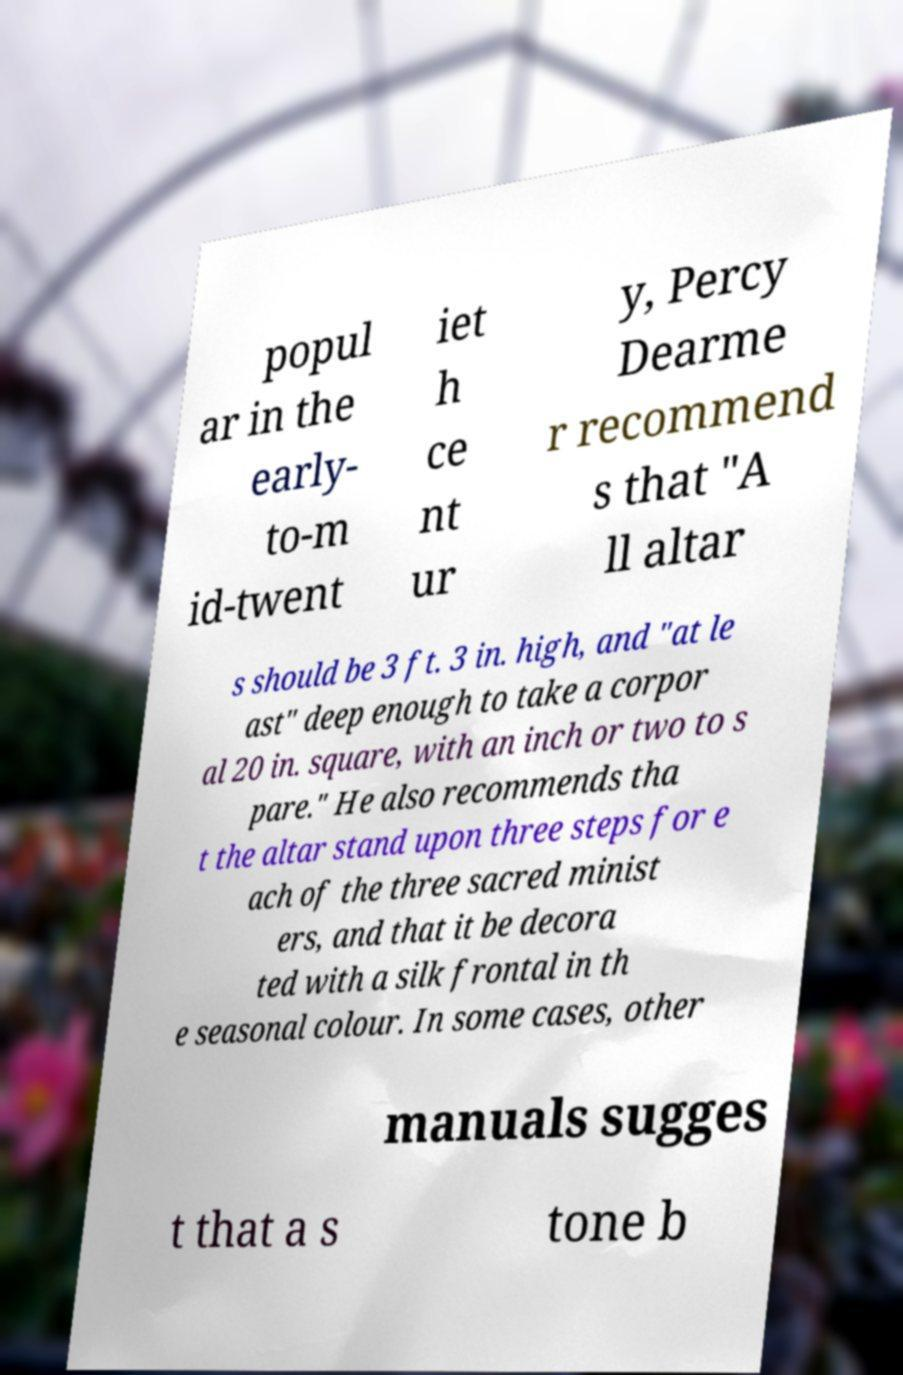For documentation purposes, I need the text within this image transcribed. Could you provide that? popul ar in the early- to-m id-twent iet h ce nt ur y, Percy Dearme r recommend s that "A ll altar s should be 3 ft. 3 in. high, and "at le ast" deep enough to take a corpor al 20 in. square, with an inch or two to s pare." He also recommends tha t the altar stand upon three steps for e ach of the three sacred minist ers, and that it be decora ted with a silk frontal in th e seasonal colour. In some cases, other manuals sugges t that a s tone b 